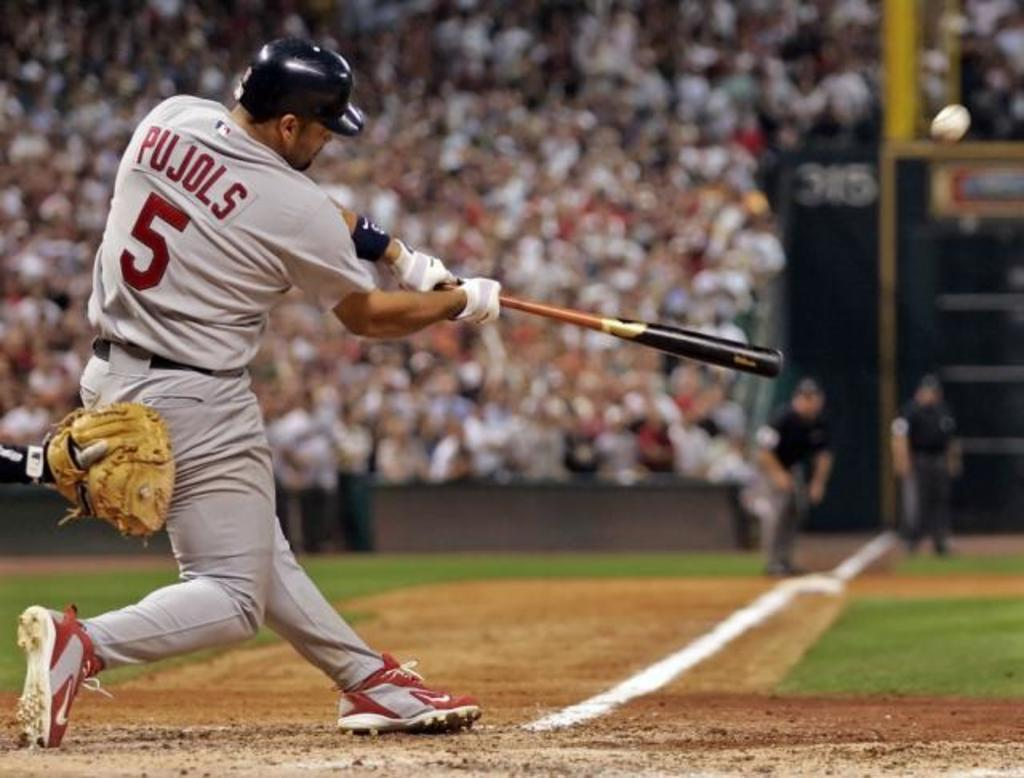Provide a one-sentence caption for the provided image. Player number 5 who is at bat swings his bat at a baseball. 